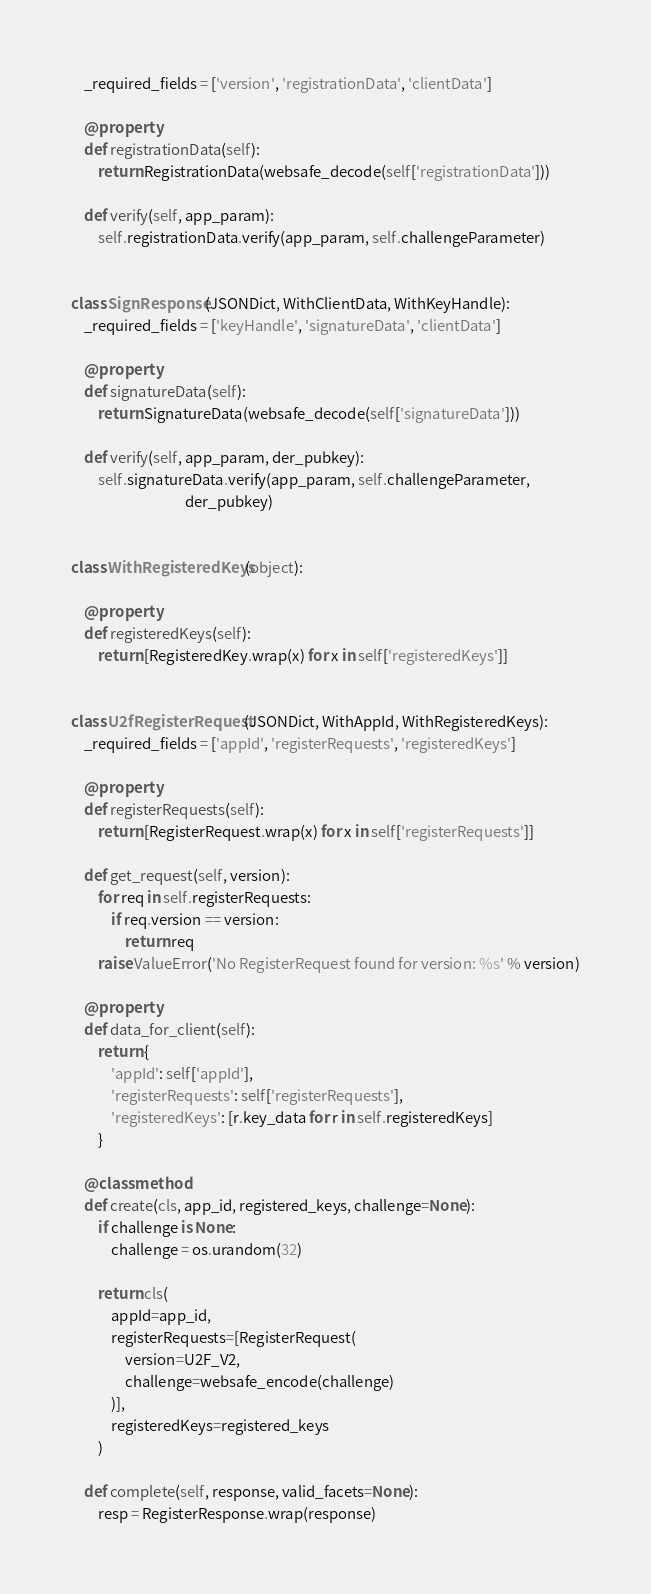<code> <loc_0><loc_0><loc_500><loc_500><_Python_>    _required_fields = ['version', 'registrationData', 'clientData']

    @property
    def registrationData(self):
        return RegistrationData(websafe_decode(self['registrationData']))

    def verify(self, app_param):
        self.registrationData.verify(app_param, self.challengeParameter)


class SignResponse(JSONDict, WithClientData, WithKeyHandle):
    _required_fields = ['keyHandle', 'signatureData', 'clientData']

    @property
    def signatureData(self):
        return SignatureData(websafe_decode(self['signatureData']))

    def verify(self, app_param, der_pubkey):
        self.signatureData.verify(app_param, self.challengeParameter,
                                  der_pubkey)


class WithRegisteredKeys(object):

    @property
    def registeredKeys(self):
        return [RegisteredKey.wrap(x) for x in self['registeredKeys']]


class U2fRegisterRequest(JSONDict, WithAppId, WithRegisteredKeys):
    _required_fields = ['appId', 'registerRequests', 'registeredKeys']

    @property
    def registerRequests(self):
        return [RegisterRequest.wrap(x) for x in self['registerRequests']]

    def get_request(self, version):
        for req in self.registerRequests:
            if req.version == version:
                return req
        raise ValueError('No RegisterRequest found for version: %s' % version)

    @property
    def data_for_client(self):
        return {
            'appId': self['appId'],
            'registerRequests': self['registerRequests'],
            'registeredKeys': [r.key_data for r in self.registeredKeys]
        }

    @classmethod
    def create(cls, app_id, registered_keys, challenge=None):
        if challenge is None:
            challenge = os.urandom(32)

        return cls(
            appId=app_id,
            registerRequests=[RegisterRequest(
                version=U2F_V2,
                challenge=websafe_encode(challenge)
            )],
            registeredKeys=registered_keys
        )

    def complete(self, response, valid_facets=None):
        resp = RegisterResponse.wrap(response)</code> 